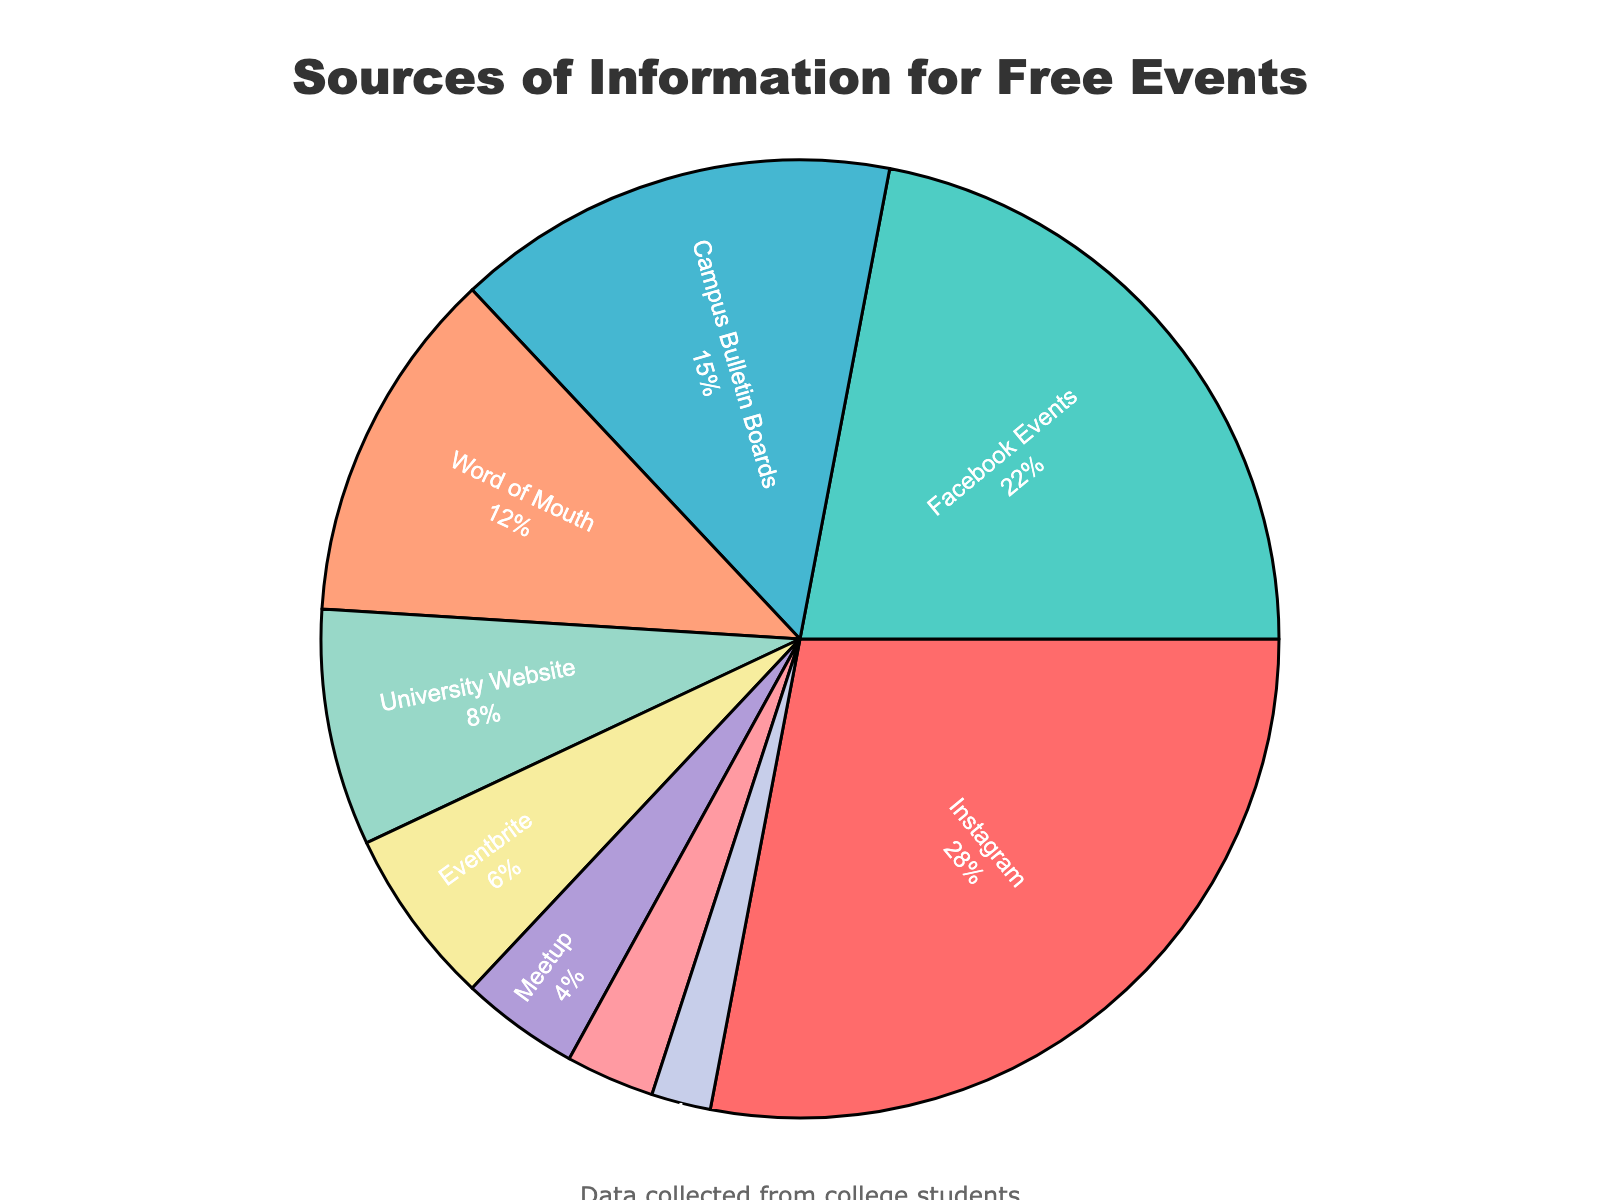What is the most common source of information for discovering free events? The pie chart shows that Instagram occupies the largest slice of the pie, indicating it is the most common source.
Answer: Instagram Which two sources of information have the smallest percentages, and what are their combined total? The pie chart segments for Twitter (2%) and Local Newspaper (3%) are the smallest. Adding these two gives 2% + 3% = 5%.
Answer: Twitter and Local Newspaper, 5% How much more popular is Facebook Events compared to Word of Mouth? Facebook Events at 22% is larger than Word of Mouth at 12%. The difference between them is 22% - 12% = 10%.
Answer: 10% If you combine the percentages of social media sources (Instagram, Facebook Events, and Twitter), what is the total percentage? Instagram (28%), Facebook Events (22%), and Twitter (2%) are all social media sources. Adding these gives 28% + 22% + 2% = 52%.
Answer: 52% What is the combined percentage for traditional sources like Local Newspaper and Campus Bulletin Boards? The percentages for Local Newspaper and Campus Bulletin Boards are 3% and 15%, respectively. The combined percentage is 3% + 15% = 18%.
Answer: 18% Which information source is depicted with the fourth largest segment and what is its percentage? The fourth largest segment in the pie chart represents Word of Mouth, which has a percentage of 12%.
Answer: Word of Mouth, 12% What is the relative size of the University Website segment compared to the Eventbrite segment? The University Website segment is 8%, and the Eventbrite segment is 6%. The University Website is larger by 8% - 6% = 2%.
Answer: 2% How do the percentages of Meetup and Local Newspaper compare? Meetup has a percentage of 4% while Local Newspaper has 3%. Meetup is larger.
Answer: Meetup is larger What sources of information are depicted in shades of blue, and what are their percentages? The segments in shades of blue represent Facebook Events, Twitter, and Meetup. Their percentages are 22%, 2%, and 4%, respectively.
Answer: Facebook Events (22%), Twitter (2%), Meetup (4%) What is the total percentage of sources other than social media platforms (Instagram, Facebook Events, Twitter)? The total percentage of the remaining sources (Campus Bulletin Boards, Word of Mouth, University Website, Eventbrite, Meetup, Local Newspaper) is 15% + 12% + 8% + 6% + 4% + 3% = 48%.
Answer: 48% 